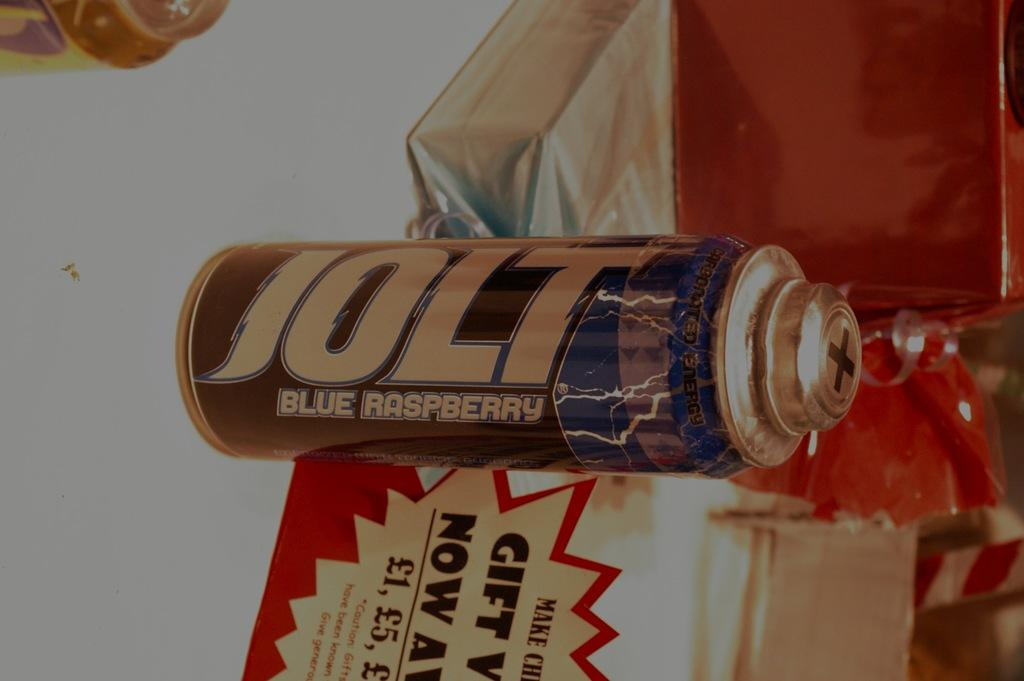What type of container is present in the image? There is a tin in the image. What other objects can be seen in the image? There are a few boxes in the image. Where are the objects located? The objects are on a surface. What type of tub is visible in the image? There is no tub present in the image. How does the tin show care for the environment in the image? The tin itself does not demonstrate care for the environment; it is simply a container. 